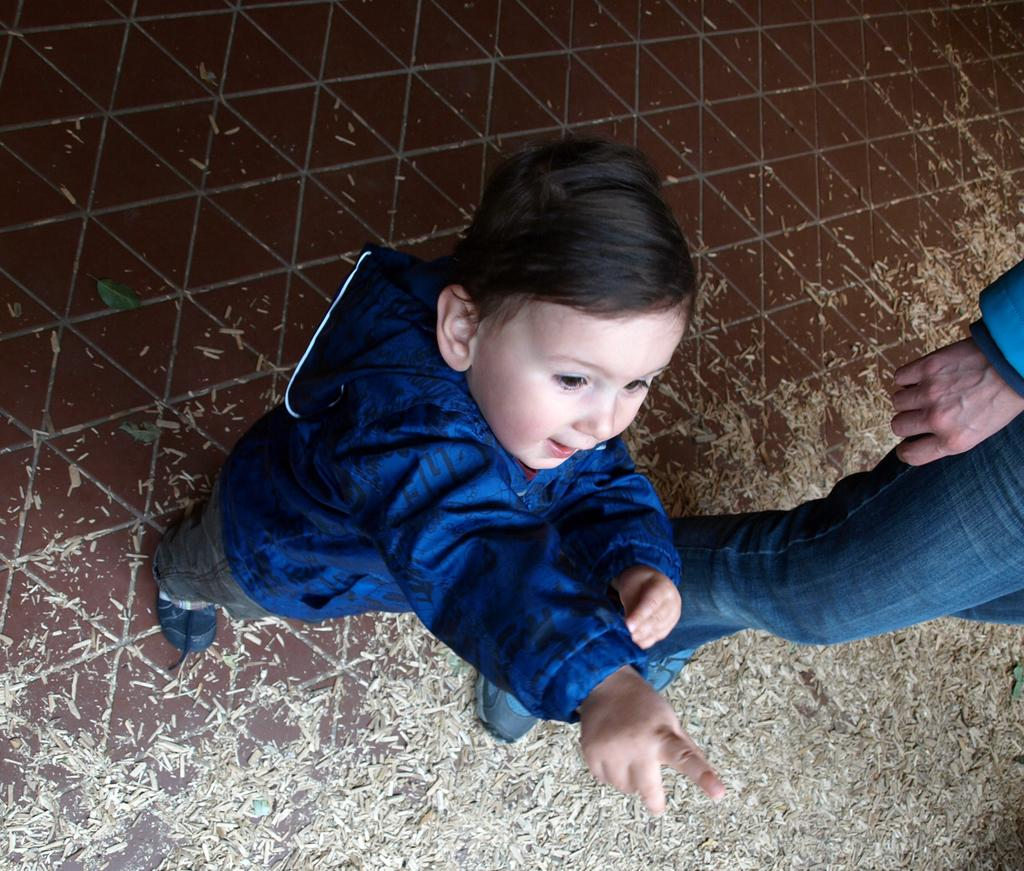Who is present in the image? There is a child and a man in the image. What are the positions of the child and the man in the image? Both the child and the man are standing on the ground. How many plates are visible in the image? There are no plates present in the image. What type of cough is the child experiencing in the image? There is no indication of a cough in the image; both the child and the man appear to be standing without any visible discomfort. 